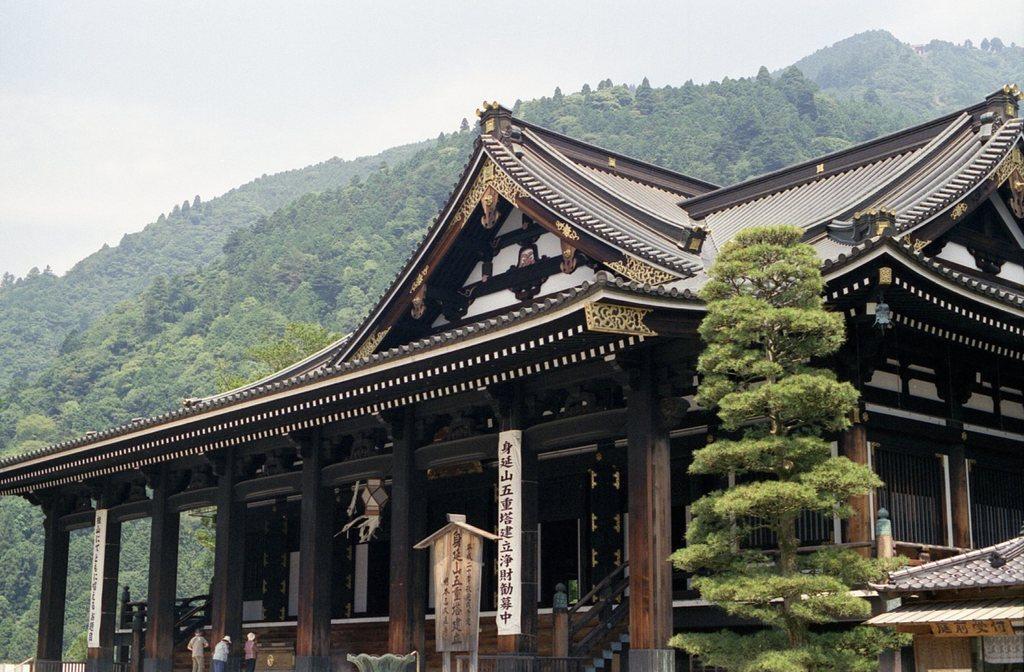Describe this image in one or two sentences. In this image we can see a building, trees and also the hills. We can also see the boards and also the people. Sky is also visible in this image. 